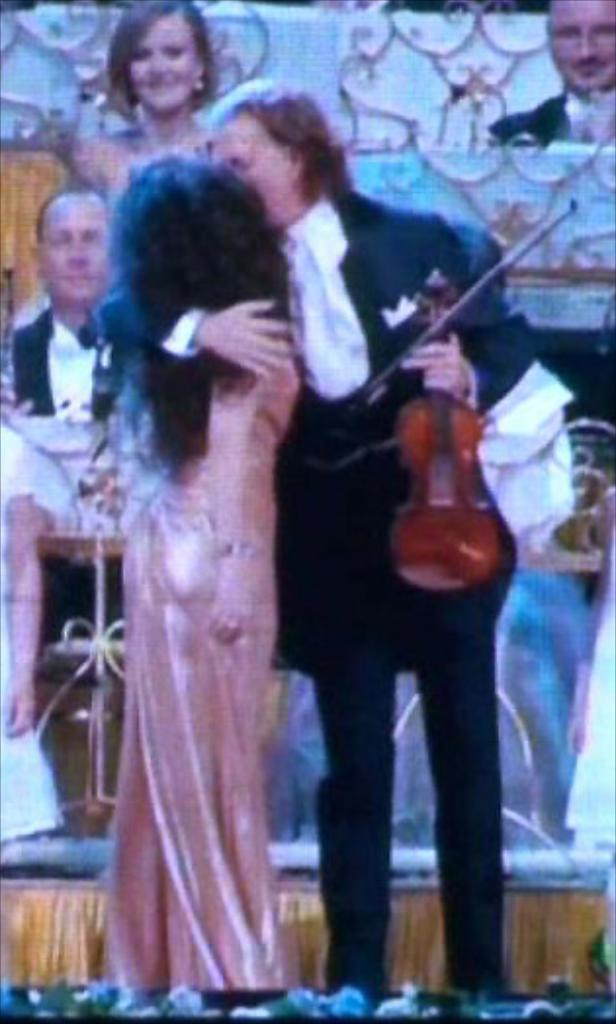What is the man in the image holding? The man is holding a musical instrument. Can you describe the woman's position in the image? The woman is in the man's hands. What can be seen in the background of the image? There are people sitting in the background of the image. What type of whistle can be heard coming from the woman in the image? There is no whistle present in the image, and the woman is not making any sounds. Can you describe the woman's mother in the image? There is no mention of the woman's mother in the image, and we cannot assume the presence of a mother based on the provided facts. 